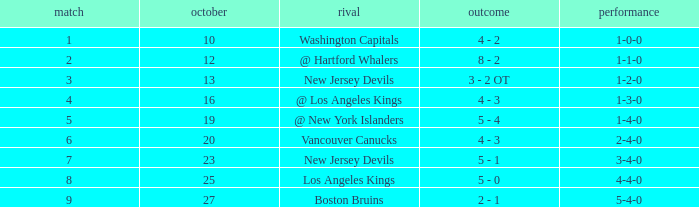Which game has the highest score in October with 9? 27.0. 